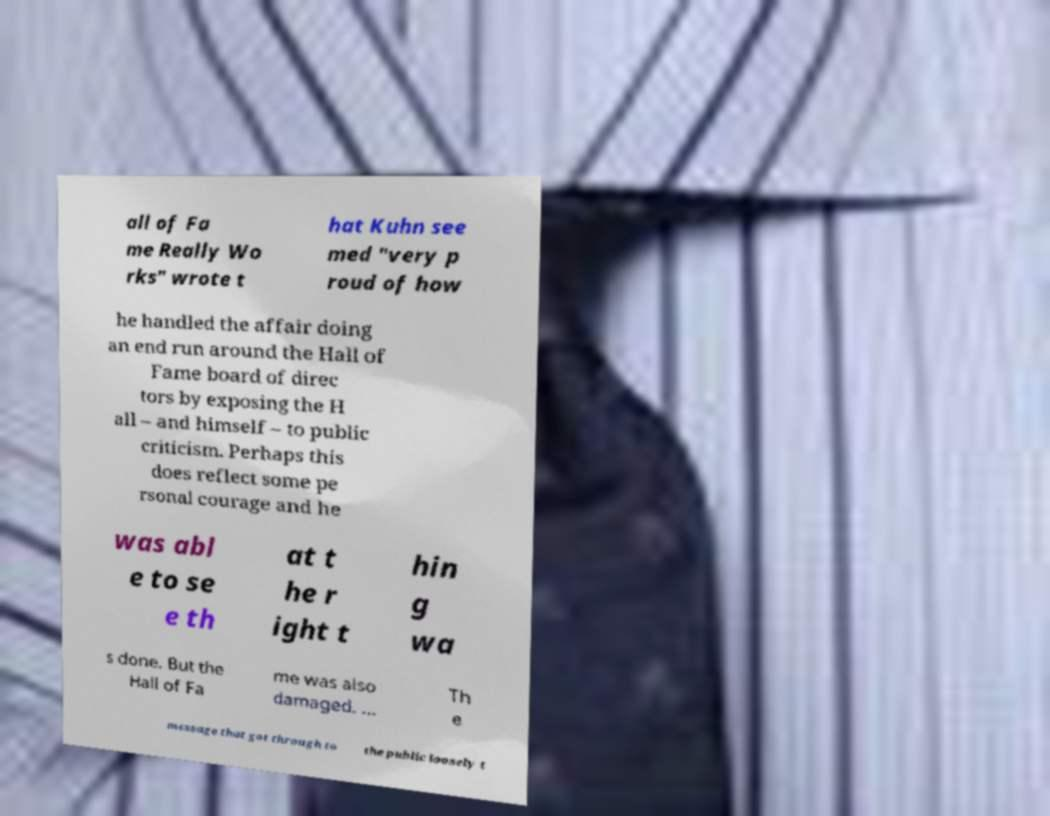For documentation purposes, I need the text within this image transcribed. Could you provide that? all of Fa me Really Wo rks" wrote t hat Kuhn see med "very p roud of how he handled the affair doing an end run around the Hall of Fame board of direc tors by exposing the H all – and himself – to public criticism. Perhaps this does reflect some pe rsonal courage and he was abl e to se e th at t he r ight t hin g wa s done. But the Hall of Fa me was also damaged. ... Th e message that got through to the public loosely t 